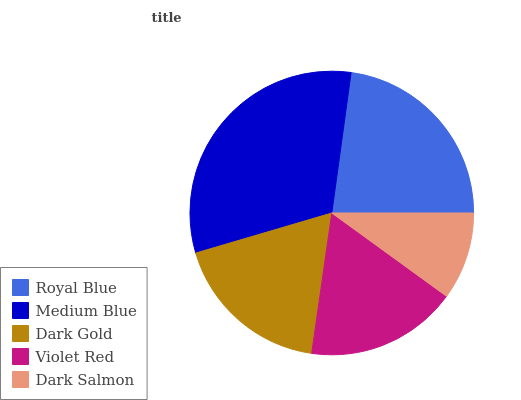Is Dark Salmon the minimum?
Answer yes or no. Yes. Is Medium Blue the maximum?
Answer yes or no. Yes. Is Dark Gold the minimum?
Answer yes or no. No. Is Dark Gold the maximum?
Answer yes or no. No. Is Medium Blue greater than Dark Gold?
Answer yes or no. Yes. Is Dark Gold less than Medium Blue?
Answer yes or no. Yes. Is Dark Gold greater than Medium Blue?
Answer yes or no. No. Is Medium Blue less than Dark Gold?
Answer yes or no. No. Is Dark Gold the high median?
Answer yes or no. Yes. Is Dark Gold the low median?
Answer yes or no. Yes. Is Royal Blue the high median?
Answer yes or no. No. Is Medium Blue the low median?
Answer yes or no. No. 